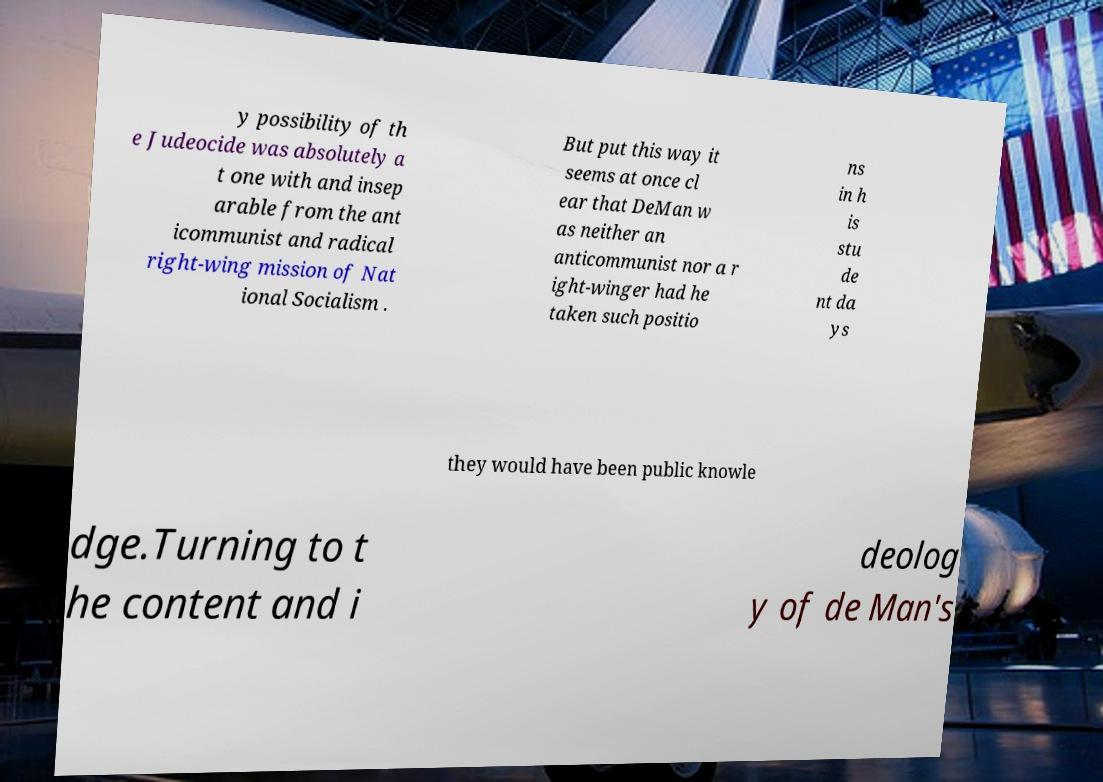Can you accurately transcribe the text from the provided image for me? y possibility of th e Judeocide was absolutely a t one with and insep arable from the ant icommunist and radical right-wing mission of Nat ional Socialism . But put this way it seems at once cl ear that DeMan w as neither an anticommunist nor a r ight-winger had he taken such positio ns in h is stu de nt da ys they would have been public knowle dge.Turning to t he content and i deolog y of de Man's 